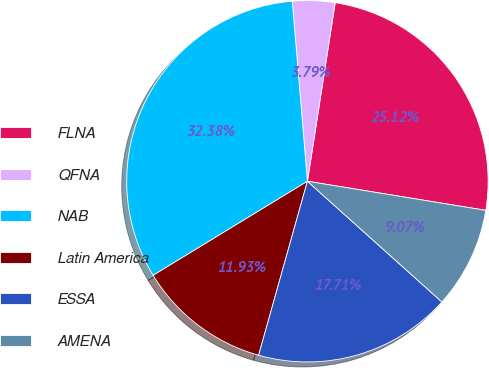<chart> <loc_0><loc_0><loc_500><loc_500><pie_chart><fcel>FLNA<fcel>QFNA<fcel>NAB<fcel>Latin America<fcel>ESSA<fcel>AMENA<nl><fcel>25.12%<fcel>3.79%<fcel>32.38%<fcel>11.93%<fcel>17.71%<fcel>9.07%<nl></chart> 